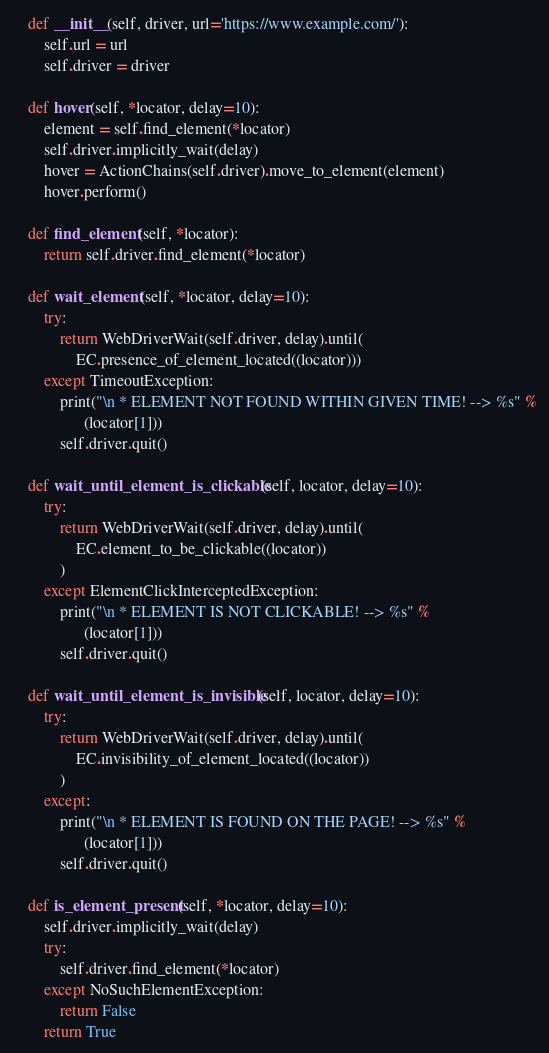Convert code to text. <code><loc_0><loc_0><loc_500><loc_500><_Python_>
    def __init__(self, driver, url='https://www.example.com/'):
        self.url = url
        self.driver = driver

    def hover(self, *locator, delay=10):
        element = self.find_element(*locator)
        self.driver.implicitly_wait(delay)
        hover = ActionChains(self.driver).move_to_element(element)
        hover.perform()

    def find_element(self, *locator):
        return self.driver.find_element(*locator)

    def wait_element(self, *locator, delay=10):
        try:
            return WebDriverWait(self.driver, delay).until(
                EC.presence_of_element_located((locator)))
        except TimeoutException:
            print("\n * ELEMENT NOT FOUND WITHIN GIVEN TIME! --> %s" %
                  (locator[1]))
            self.driver.quit()

    def wait_until_element_is_clickable(self, locator, delay=10):
        try:
            return WebDriverWait(self.driver, delay).until(
                EC.element_to_be_clickable((locator))
            )
        except ElementClickInterceptedException:
            print("\n * ELEMENT IS NOT CLICKABLE! --> %s" %
                  (locator[1]))
            self.driver.quit()

    def wait_until_element_is_invisible(self, locator, delay=10):
        try:
            return WebDriverWait(self.driver, delay).until(
                EC.invisibility_of_element_located((locator))
            )
        except:
            print("\n * ELEMENT IS FOUND ON THE PAGE! --> %s" %
                  (locator[1]))
            self.driver.quit()

    def is_element_present(self, *locator, delay=10):
        self.driver.implicitly_wait(delay)
        try:
            self.driver.find_element(*locator)
        except NoSuchElementException:
            return False
        return True
</code> 